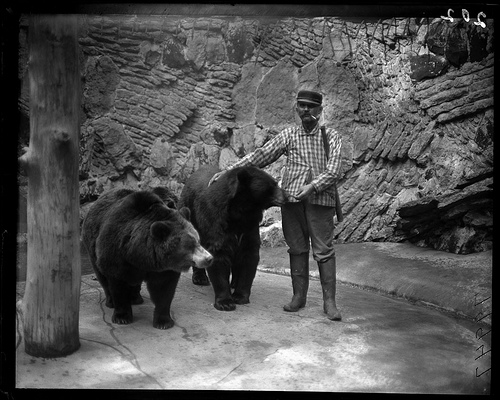What are the bears doing in this photo? The bears look relatively calm, one appears to be standing still, while the other is facing the person, who seems to be interacting with them, perhaps as a part of a feeding or training routine. 